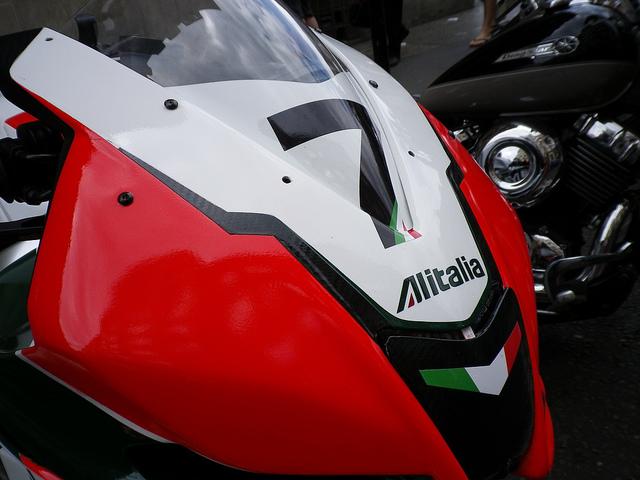What colors are the bike?
Be succinct. Red and white. Is this new?
Answer briefly. Yes. What make is the bike?
Be succinct. Alitalia. 